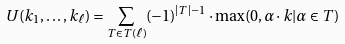<formula> <loc_0><loc_0><loc_500><loc_500>U ( k _ { 1 } , \dots , k _ { \ell } ) = \sum _ { T \in T ( \ell ) } ( - 1 ) ^ { | T | - 1 } \cdot \max ( 0 , \alpha \cdot k | \alpha \in T )</formula> 